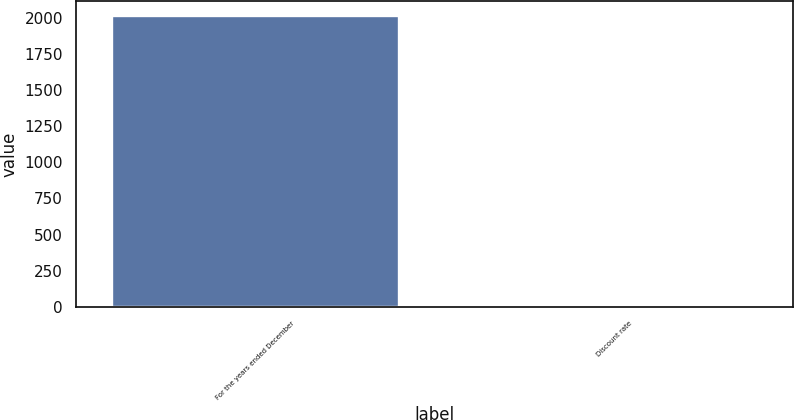Convert chart to OTSL. <chart><loc_0><loc_0><loc_500><loc_500><bar_chart><fcel>For the years ended December<fcel>Discount rate<nl><fcel>2016<fcel>4<nl></chart> 